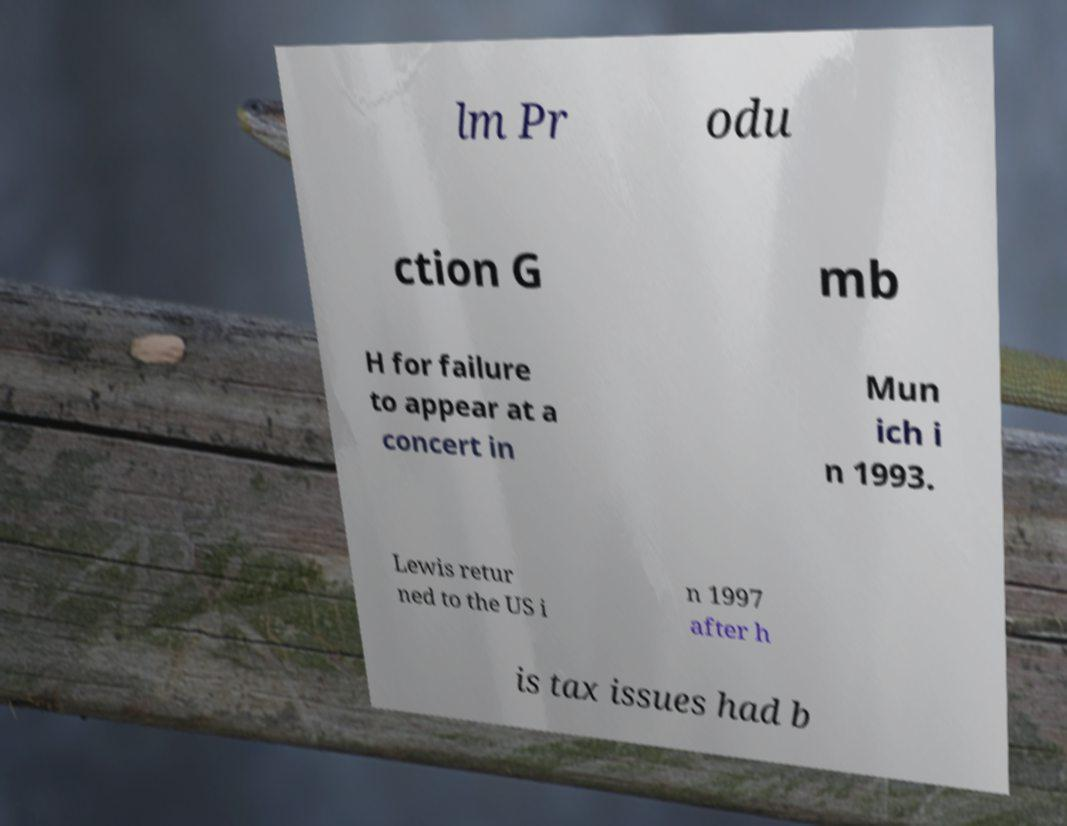Could you assist in decoding the text presented in this image and type it out clearly? lm Pr odu ction G mb H for failure to appear at a concert in Mun ich i n 1993. Lewis retur ned to the US i n 1997 after h is tax issues had b 